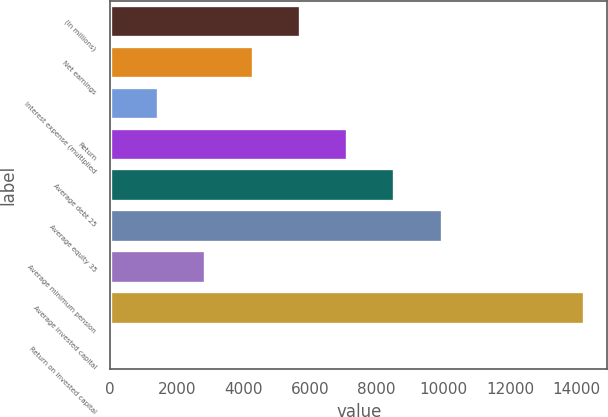<chart> <loc_0><loc_0><loc_500><loc_500><bar_chart><fcel>(In millions)<fcel>Net earnings<fcel>Interest expense (multiplied<fcel>Return<fcel>Average debt 25<fcel>Average equity 35<fcel>Average minimum pension<fcel>Average invested capital<fcel>Return on invested capital<nl><fcel>5693.5<fcel>4273.75<fcel>1434.25<fcel>7113.25<fcel>8533<fcel>9952.75<fcel>2854<fcel>14212<fcel>14.5<nl></chart> 